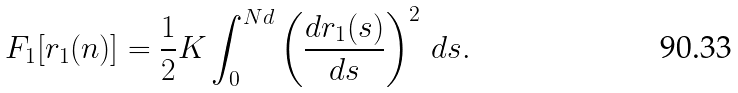<formula> <loc_0><loc_0><loc_500><loc_500>F _ { 1 } [ { r } _ { 1 } ( n ) ] = \frac { 1 } { 2 } K \int _ { 0 } ^ { N d } \left ( \frac { d { r } _ { 1 } ( s ) } { d s } \right ) ^ { 2 } \, d s .</formula> 